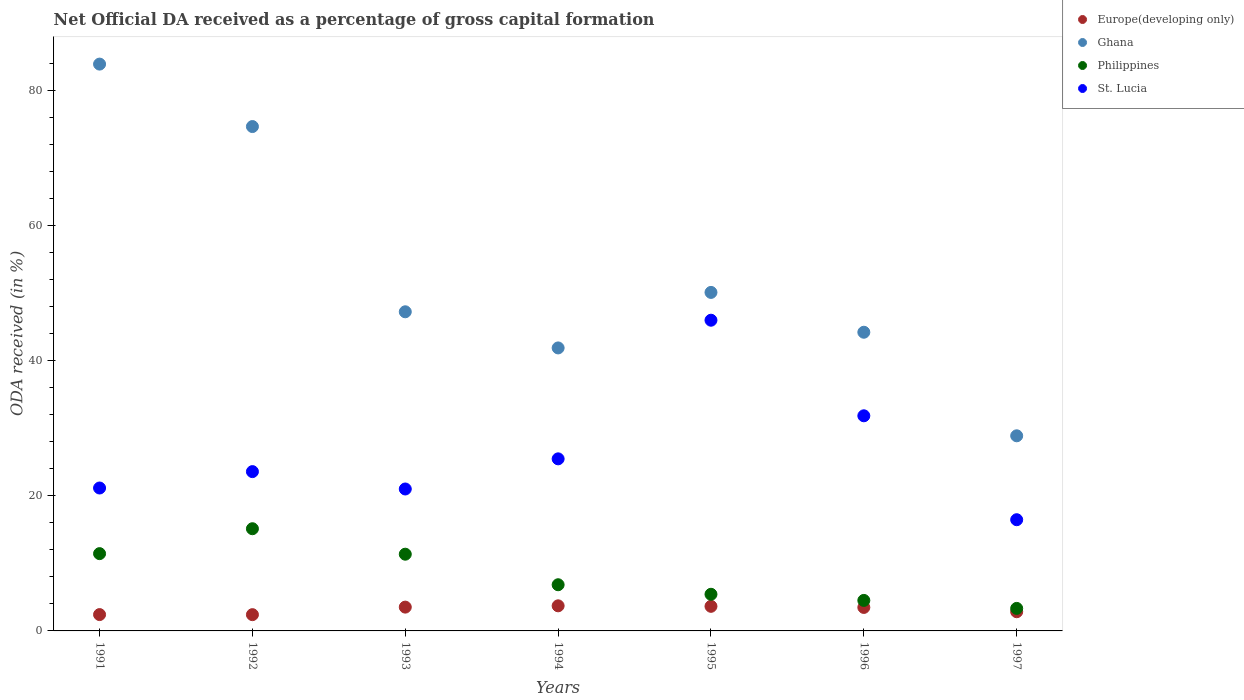What is the net ODA received in St. Lucia in 1991?
Give a very brief answer. 21.15. Across all years, what is the maximum net ODA received in St. Lucia?
Your answer should be compact. 45.98. Across all years, what is the minimum net ODA received in Ghana?
Offer a very short reply. 28.88. In which year was the net ODA received in Ghana minimum?
Your response must be concise. 1997. What is the total net ODA received in Europe(developing only) in the graph?
Your answer should be very brief. 22.01. What is the difference between the net ODA received in Ghana in 1992 and that in 1995?
Offer a very short reply. 24.55. What is the difference between the net ODA received in St. Lucia in 1993 and the net ODA received in Ghana in 1997?
Provide a short and direct response. -7.87. What is the average net ODA received in Europe(developing only) per year?
Your response must be concise. 3.14. In the year 1992, what is the difference between the net ODA received in Ghana and net ODA received in Philippines?
Make the answer very short. 59.52. In how many years, is the net ODA received in Europe(developing only) greater than 56 %?
Your answer should be compact. 0. What is the ratio of the net ODA received in St. Lucia in 1992 to that in 1995?
Your response must be concise. 0.51. What is the difference between the highest and the second highest net ODA received in Ghana?
Give a very brief answer. 9.24. What is the difference between the highest and the lowest net ODA received in Philippines?
Offer a very short reply. 11.79. In how many years, is the net ODA received in Ghana greater than the average net ODA received in Ghana taken over all years?
Provide a succinct answer. 2. Is the sum of the net ODA received in Europe(developing only) in 1991 and 1997 greater than the maximum net ODA received in Ghana across all years?
Your response must be concise. No. Does the net ODA received in Ghana monotonically increase over the years?
Make the answer very short. No. Is the net ODA received in Ghana strictly greater than the net ODA received in St. Lucia over the years?
Provide a short and direct response. Yes. How many dotlines are there?
Your response must be concise. 4. Does the graph contain grids?
Your answer should be compact. No. How are the legend labels stacked?
Your response must be concise. Vertical. What is the title of the graph?
Keep it short and to the point. Net Official DA received as a percentage of gross capital formation. What is the label or title of the X-axis?
Offer a terse response. Years. What is the label or title of the Y-axis?
Your response must be concise. ODA received (in %). What is the ODA received (in %) in Europe(developing only) in 1991?
Offer a terse response. 2.42. What is the ODA received (in %) of Ghana in 1991?
Your response must be concise. 83.88. What is the ODA received (in %) of Philippines in 1991?
Your answer should be very brief. 11.44. What is the ODA received (in %) of St. Lucia in 1991?
Your answer should be compact. 21.15. What is the ODA received (in %) in Europe(developing only) in 1992?
Provide a short and direct response. 2.41. What is the ODA received (in %) in Ghana in 1992?
Your answer should be compact. 74.64. What is the ODA received (in %) in Philippines in 1992?
Provide a succinct answer. 15.12. What is the ODA received (in %) in St. Lucia in 1992?
Offer a terse response. 23.58. What is the ODA received (in %) in Europe(developing only) in 1993?
Your response must be concise. 3.52. What is the ODA received (in %) of Ghana in 1993?
Your answer should be very brief. 47.23. What is the ODA received (in %) in Philippines in 1993?
Offer a very short reply. 11.35. What is the ODA received (in %) of St. Lucia in 1993?
Provide a short and direct response. 21. What is the ODA received (in %) in Europe(developing only) in 1994?
Give a very brief answer. 3.71. What is the ODA received (in %) in Ghana in 1994?
Provide a succinct answer. 41.88. What is the ODA received (in %) in Philippines in 1994?
Your answer should be compact. 6.83. What is the ODA received (in %) in St. Lucia in 1994?
Keep it short and to the point. 25.47. What is the ODA received (in %) of Europe(developing only) in 1995?
Give a very brief answer. 3.64. What is the ODA received (in %) in Ghana in 1995?
Give a very brief answer. 50.09. What is the ODA received (in %) of Philippines in 1995?
Your response must be concise. 5.42. What is the ODA received (in %) of St. Lucia in 1995?
Your answer should be compact. 45.98. What is the ODA received (in %) in Europe(developing only) in 1996?
Your response must be concise. 3.48. What is the ODA received (in %) of Ghana in 1996?
Your answer should be compact. 44.2. What is the ODA received (in %) in Philippines in 1996?
Give a very brief answer. 4.51. What is the ODA received (in %) of St. Lucia in 1996?
Ensure brevity in your answer.  31.84. What is the ODA received (in %) of Europe(developing only) in 1997?
Keep it short and to the point. 2.84. What is the ODA received (in %) in Ghana in 1997?
Your answer should be very brief. 28.88. What is the ODA received (in %) of Philippines in 1997?
Your response must be concise. 3.33. What is the ODA received (in %) in St. Lucia in 1997?
Provide a short and direct response. 16.46. Across all years, what is the maximum ODA received (in %) in Europe(developing only)?
Give a very brief answer. 3.71. Across all years, what is the maximum ODA received (in %) in Ghana?
Give a very brief answer. 83.88. Across all years, what is the maximum ODA received (in %) of Philippines?
Ensure brevity in your answer.  15.12. Across all years, what is the maximum ODA received (in %) in St. Lucia?
Offer a terse response. 45.98. Across all years, what is the minimum ODA received (in %) in Europe(developing only)?
Make the answer very short. 2.41. Across all years, what is the minimum ODA received (in %) in Ghana?
Offer a very short reply. 28.88. Across all years, what is the minimum ODA received (in %) of Philippines?
Keep it short and to the point. 3.33. Across all years, what is the minimum ODA received (in %) of St. Lucia?
Offer a very short reply. 16.46. What is the total ODA received (in %) of Europe(developing only) in the graph?
Provide a short and direct response. 22.01. What is the total ODA received (in %) in Ghana in the graph?
Provide a short and direct response. 370.8. What is the total ODA received (in %) in Philippines in the graph?
Make the answer very short. 58.02. What is the total ODA received (in %) of St. Lucia in the graph?
Keep it short and to the point. 185.47. What is the difference between the ODA received (in %) in Europe(developing only) in 1991 and that in 1992?
Your answer should be compact. 0.01. What is the difference between the ODA received (in %) in Ghana in 1991 and that in 1992?
Give a very brief answer. 9.24. What is the difference between the ODA received (in %) in Philippines in 1991 and that in 1992?
Ensure brevity in your answer.  -3.69. What is the difference between the ODA received (in %) in St. Lucia in 1991 and that in 1992?
Your answer should be compact. -2.43. What is the difference between the ODA received (in %) in Europe(developing only) in 1991 and that in 1993?
Provide a short and direct response. -1.1. What is the difference between the ODA received (in %) of Ghana in 1991 and that in 1993?
Offer a very short reply. 36.65. What is the difference between the ODA received (in %) in Philippines in 1991 and that in 1993?
Offer a very short reply. 0.08. What is the difference between the ODA received (in %) in St. Lucia in 1991 and that in 1993?
Offer a very short reply. 0.14. What is the difference between the ODA received (in %) of Europe(developing only) in 1991 and that in 1994?
Make the answer very short. -1.3. What is the difference between the ODA received (in %) in Ghana in 1991 and that in 1994?
Give a very brief answer. 42. What is the difference between the ODA received (in %) of Philippines in 1991 and that in 1994?
Keep it short and to the point. 4.6. What is the difference between the ODA received (in %) in St. Lucia in 1991 and that in 1994?
Keep it short and to the point. -4.32. What is the difference between the ODA received (in %) of Europe(developing only) in 1991 and that in 1995?
Make the answer very short. -1.22. What is the difference between the ODA received (in %) of Ghana in 1991 and that in 1995?
Your response must be concise. 33.79. What is the difference between the ODA received (in %) in Philippines in 1991 and that in 1995?
Your answer should be very brief. 6.01. What is the difference between the ODA received (in %) in St. Lucia in 1991 and that in 1995?
Provide a succinct answer. -24.83. What is the difference between the ODA received (in %) of Europe(developing only) in 1991 and that in 1996?
Ensure brevity in your answer.  -1.06. What is the difference between the ODA received (in %) of Ghana in 1991 and that in 1996?
Offer a very short reply. 39.68. What is the difference between the ODA received (in %) of Philippines in 1991 and that in 1996?
Ensure brevity in your answer.  6.92. What is the difference between the ODA received (in %) of St. Lucia in 1991 and that in 1996?
Offer a terse response. -10.69. What is the difference between the ODA received (in %) in Europe(developing only) in 1991 and that in 1997?
Provide a short and direct response. -0.42. What is the difference between the ODA received (in %) in Ghana in 1991 and that in 1997?
Your answer should be compact. 55.01. What is the difference between the ODA received (in %) of Philippines in 1991 and that in 1997?
Offer a terse response. 8.1. What is the difference between the ODA received (in %) in St. Lucia in 1991 and that in 1997?
Make the answer very short. 4.69. What is the difference between the ODA received (in %) in Europe(developing only) in 1992 and that in 1993?
Your answer should be very brief. -1.12. What is the difference between the ODA received (in %) in Ghana in 1992 and that in 1993?
Provide a short and direct response. 27.41. What is the difference between the ODA received (in %) in Philippines in 1992 and that in 1993?
Keep it short and to the point. 3.77. What is the difference between the ODA received (in %) of St. Lucia in 1992 and that in 1993?
Provide a succinct answer. 2.57. What is the difference between the ODA received (in %) of Europe(developing only) in 1992 and that in 1994?
Ensure brevity in your answer.  -1.31. What is the difference between the ODA received (in %) in Ghana in 1992 and that in 1994?
Ensure brevity in your answer.  32.76. What is the difference between the ODA received (in %) in Philippines in 1992 and that in 1994?
Offer a terse response. 8.29. What is the difference between the ODA received (in %) in St. Lucia in 1992 and that in 1994?
Make the answer very short. -1.89. What is the difference between the ODA received (in %) in Europe(developing only) in 1992 and that in 1995?
Provide a short and direct response. -1.23. What is the difference between the ODA received (in %) in Ghana in 1992 and that in 1995?
Make the answer very short. 24.55. What is the difference between the ODA received (in %) in Philippines in 1992 and that in 1995?
Offer a very short reply. 9.7. What is the difference between the ODA received (in %) in St. Lucia in 1992 and that in 1995?
Ensure brevity in your answer.  -22.41. What is the difference between the ODA received (in %) in Europe(developing only) in 1992 and that in 1996?
Provide a short and direct response. -1.07. What is the difference between the ODA received (in %) of Ghana in 1992 and that in 1996?
Ensure brevity in your answer.  30.44. What is the difference between the ODA received (in %) of Philippines in 1992 and that in 1996?
Make the answer very short. 10.61. What is the difference between the ODA received (in %) of St. Lucia in 1992 and that in 1996?
Your answer should be very brief. -8.26. What is the difference between the ODA received (in %) in Europe(developing only) in 1992 and that in 1997?
Your answer should be very brief. -0.43. What is the difference between the ODA received (in %) of Ghana in 1992 and that in 1997?
Offer a terse response. 45.76. What is the difference between the ODA received (in %) in Philippines in 1992 and that in 1997?
Ensure brevity in your answer.  11.79. What is the difference between the ODA received (in %) of St. Lucia in 1992 and that in 1997?
Your answer should be compact. 7.12. What is the difference between the ODA received (in %) of Europe(developing only) in 1993 and that in 1994?
Offer a very short reply. -0.19. What is the difference between the ODA received (in %) in Ghana in 1993 and that in 1994?
Provide a short and direct response. 5.35. What is the difference between the ODA received (in %) of Philippines in 1993 and that in 1994?
Make the answer very short. 4.52. What is the difference between the ODA received (in %) in St. Lucia in 1993 and that in 1994?
Offer a terse response. -4.46. What is the difference between the ODA received (in %) of Europe(developing only) in 1993 and that in 1995?
Your response must be concise. -0.12. What is the difference between the ODA received (in %) in Ghana in 1993 and that in 1995?
Offer a very short reply. -2.87. What is the difference between the ODA received (in %) of Philippines in 1993 and that in 1995?
Your answer should be compact. 5.93. What is the difference between the ODA received (in %) of St. Lucia in 1993 and that in 1995?
Offer a terse response. -24.98. What is the difference between the ODA received (in %) of Europe(developing only) in 1993 and that in 1996?
Offer a very short reply. 0.05. What is the difference between the ODA received (in %) in Ghana in 1993 and that in 1996?
Your response must be concise. 3.03. What is the difference between the ODA received (in %) of Philippines in 1993 and that in 1996?
Offer a terse response. 6.84. What is the difference between the ODA received (in %) in St. Lucia in 1993 and that in 1996?
Your answer should be compact. -10.83. What is the difference between the ODA received (in %) of Europe(developing only) in 1993 and that in 1997?
Offer a very short reply. 0.68. What is the difference between the ODA received (in %) of Ghana in 1993 and that in 1997?
Offer a terse response. 18.35. What is the difference between the ODA received (in %) of Philippines in 1993 and that in 1997?
Keep it short and to the point. 8.02. What is the difference between the ODA received (in %) in St. Lucia in 1993 and that in 1997?
Ensure brevity in your answer.  4.55. What is the difference between the ODA received (in %) in Europe(developing only) in 1994 and that in 1995?
Keep it short and to the point. 0.07. What is the difference between the ODA received (in %) in Ghana in 1994 and that in 1995?
Offer a terse response. -8.21. What is the difference between the ODA received (in %) in Philippines in 1994 and that in 1995?
Your answer should be compact. 1.41. What is the difference between the ODA received (in %) in St. Lucia in 1994 and that in 1995?
Your answer should be compact. -20.51. What is the difference between the ODA received (in %) of Europe(developing only) in 1994 and that in 1996?
Give a very brief answer. 0.24. What is the difference between the ODA received (in %) of Ghana in 1994 and that in 1996?
Your response must be concise. -2.32. What is the difference between the ODA received (in %) in Philippines in 1994 and that in 1996?
Offer a terse response. 2.32. What is the difference between the ODA received (in %) in St. Lucia in 1994 and that in 1996?
Your response must be concise. -6.37. What is the difference between the ODA received (in %) of Europe(developing only) in 1994 and that in 1997?
Provide a succinct answer. 0.88. What is the difference between the ODA received (in %) of Ghana in 1994 and that in 1997?
Offer a very short reply. 13. What is the difference between the ODA received (in %) of Philippines in 1994 and that in 1997?
Your answer should be very brief. 3.5. What is the difference between the ODA received (in %) in St. Lucia in 1994 and that in 1997?
Give a very brief answer. 9.01. What is the difference between the ODA received (in %) of Europe(developing only) in 1995 and that in 1996?
Keep it short and to the point. 0.16. What is the difference between the ODA received (in %) in Ghana in 1995 and that in 1996?
Provide a short and direct response. 5.89. What is the difference between the ODA received (in %) in Philippines in 1995 and that in 1996?
Your answer should be compact. 0.91. What is the difference between the ODA received (in %) in St. Lucia in 1995 and that in 1996?
Ensure brevity in your answer.  14.14. What is the difference between the ODA received (in %) in Europe(developing only) in 1995 and that in 1997?
Make the answer very short. 0.8. What is the difference between the ODA received (in %) of Ghana in 1995 and that in 1997?
Your answer should be compact. 21.22. What is the difference between the ODA received (in %) in Philippines in 1995 and that in 1997?
Give a very brief answer. 2.09. What is the difference between the ODA received (in %) in St. Lucia in 1995 and that in 1997?
Offer a terse response. 29.52. What is the difference between the ODA received (in %) in Europe(developing only) in 1996 and that in 1997?
Provide a succinct answer. 0.64. What is the difference between the ODA received (in %) of Ghana in 1996 and that in 1997?
Your answer should be compact. 15.32. What is the difference between the ODA received (in %) of Philippines in 1996 and that in 1997?
Offer a terse response. 1.18. What is the difference between the ODA received (in %) in St. Lucia in 1996 and that in 1997?
Make the answer very short. 15.38. What is the difference between the ODA received (in %) of Europe(developing only) in 1991 and the ODA received (in %) of Ghana in 1992?
Keep it short and to the point. -72.22. What is the difference between the ODA received (in %) of Europe(developing only) in 1991 and the ODA received (in %) of Philippines in 1992?
Your response must be concise. -12.71. What is the difference between the ODA received (in %) of Europe(developing only) in 1991 and the ODA received (in %) of St. Lucia in 1992?
Provide a succinct answer. -21.16. What is the difference between the ODA received (in %) of Ghana in 1991 and the ODA received (in %) of Philippines in 1992?
Provide a short and direct response. 68.76. What is the difference between the ODA received (in %) of Ghana in 1991 and the ODA received (in %) of St. Lucia in 1992?
Keep it short and to the point. 60.31. What is the difference between the ODA received (in %) in Philippines in 1991 and the ODA received (in %) in St. Lucia in 1992?
Offer a terse response. -12.14. What is the difference between the ODA received (in %) in Europe(developing only) in 1991 and the ODA received (in %) in Ghana in 1993?
Keep it short and to the point. -44.81. What is the difference between the ODA received (in %) in Europe(developing only) in 1991 and the ODA received (in %) in Philippines in 1993?
Offer a very short reply. -8.94. What is the difference between the ODA received (in %) in Europe(developing only) in 1991 and the ODA received (in %) in St. Lucia in 1993?
Offer a terse response. -18.59. What is the difference between the ODA received (in %) in Ghana in 1991 and the ODA received (in %) in Philippines in 1993?
Your answer should be compact. 72.53. What is the difference between the ODA received (in %) in Ghana in 1991 and the ODA received (in %) in St. Lucia in 1993?
Your answer should be compact. 62.88. What is the difference between the ODA received (in %) of Philippines in 1991 and the ODA received (in %) of St. Lucia in 1993?
Ensure brevity in your answer.  -9.57. What is the difference between the ODA received (in %) in Europe(developing only) in 1991 and the ODA received (in %) in Ghana in 1994?
Your answer should be very brief. -39.46. What is the difference between the ODA received (in %) of Europe(developing only) in 1991 and the ODA received (in %) of Philippines in 1994?
Offer a terse response. -4.42. What is the difference between the ODA received (in %) in Europe(developing only) in 1991 and the ODA received (in %) in St. Lucia in 1994?
Provide a short and direct response. -23.05. What is the difference between the ODA received (in %) in Ghana in 1991 and the ODA received (in %) in Philippines in 1994?
Provide a short and direct response. 77.05. What is the difference between the ODA received (in %) of Ghana in 1991 and the ODA received (in %) of St. Lucia in 1994?
Your answer should be compact. 58.42. What is the difference between the ODA received (in %) of Philippines in 1991 and the ODA received (in %) of St. Lucia in 1994?
Provide a short and direct response. -14.03. What is the difference between the ODA received (in %) in Europe(developing only) in 1991 and the ODA received (in %) in Ghana in 1995?
Offer a very short reply. -47.68. What is the difference between the ODA received (in %) in Europe(developing only) in 1991 and the ODA received (in %) in Philippines in 1995?
Provide a short and direct response. -3. What is the difference between the ODA received (in %) in Europe(developing only) in 1991 and the ODA received (in %) in St. Lucia in 1995?
Give a very brief answer. -43.56. What is the difference between the ODA received (in %) of Ghana in 1991 and the ODA received (in %) of Philippines in 1995?
Ensure brevity in your answer.  78.46. What is the difference between the ODA received (in %) of Ghana in 1991 and the ODA received (in %) of St. Lucia in 1995?
Provide a short and direct response. 37.9. What is the difference between the ODA received (in %) of Philippines in 1991 and the ODA received (in %) of St. Lucia in 1995?
Offer a terse response. -34.54. What is the difference between the ODA received (in %) of Europe(developing only) in 1991 and the ODA received (in %) of Ghana in 1996?
Provide a short and direct response. -41.78. What is the difference between the ODA received (in %) in Europe(developing only) in 1991 and the ODA received (in %) in Philippines in 1996?
Make the answer very short. -2.1. What is the difference between the ODA received (in %) in Europe(developing only) in 1991 and the ODA received (in %) in St. Lucia in 1996?
Ensure brevity in your answer.  -29.42. What is the difference between the ODA received (in %) in Ghana in 1991 and the ODA received (in %) in Philippines in 1996?
Give a very brief answer. 79.37. What is the difference between the ODA received (in %) in Ghana in 1991 and the ODA received (in %) in St. Lucia in 1996?
Ensure brevity in your answer.  52.05. What is the difference between the ODA received (in %) in Philippines in 1991 and the ODA received (in %) in St. Lucia in 1996?
Ensure brevity in your answer.  -20.4. What is the difference between the ODA received (in %) in Europe(developing only) in 1991 and the ODA received (in %) in Ghana in 1997?
Provide a short and direct response. -26.46. What is the difference between the ODA received (in %) of Europe(developing only) in 1991 and the ODA received (in %) of Philippines in 1997?
Make the answer very short. -0.91. What is the difference between the ODA received (in %) in Europe(developing only) in 1991 and the ODA received (in %) in St. Lucia in 1997?
Your response must be concise. -14.04. What is the difference between the ODA received (in %) in Ghana in 1991 and the ODA received (in %) in Philippines in 1997?
Your answer should be compact. 80.55. What is the difference between the ODA received (in %) in Ghana in 1991 and the ODA received (in %) in St. Lucia in 1997?
Provide a short and direct response. 67.42. What is the difference between the ODA received (in %) in Philippines in 1991 and the ODA received (in %) in St. Lucia in 1997?
Ensure brevity in your answer.  -5.02. What is the difference between the ODA received (in %) in Europe(developing only) in 1992 and the ODA received (in %) in Ghana in 1993?
Your answer should be very brief. -44.82. What is the difference between the ODA received (in %) in Europe(developing only) in 1992 and the ODA received (in %) in Philippines in 1993?
Your answer should be compact. -8.95. What is the difference between the ODA received (in %) of Europe(developing only) in 1992 and the ODA received (in %) of St. Lucia in 1993?
Your answer should be compact. -18.6. What is the difference between the ODA received (in %) of Ghana in 1992 and the ODA received (in %) of Philippines in 1993?
Keep it short and to the point. 63.29. What is the difference between the ODA received (in %) in Ghana in 1992 and the ODA received (in %) in St. Lucia in 1993?
Offer a very short reply. 53.64. What is the difference between the ODA received (in %) in Philippines in 1992 and the ODA received (in %) in St. Lucia in 1993?
Provide a short and direct response. -5.88. What is the difference between the ODA received (in %) in Europe(developing only) in 1992 and the ODA received (in %) in Ghana in 1994?
Your answer should be compact. -39.47. What is the difference between the ODA received (in %) of Europe(developing only) in 1992 and the ODA received (in %) of Philippines in 1994?
Provide a succinct answer. -4.43. What is the difference between the ODA received (in %) of Europe(developing only) in 1992 and the ODA received (in %) of St. Lucia in 1994?
Keep it short and to the point. -23.06. What is the difference between the ODA received (in %) of Ghana in 1992 and the ODA received (in %) of Philippines in 1994?
Provide a short and direct response. 67.81. What is the difference between the ODA received (in %) in Ghana in 1992 and the ODA received (in %) in St. Lucia in 1994?
Your answer should be very brief. 49.17. What is the difference between the ODA received (in %) of Philippines in 1992 and the ODA received (in %) of St. Lucia in 1994?
Offer a terse response. -10.34. What is the difference between the ODA received (in %) of Europe(developing only) in 1992 and the ODA received (in %) of Ghana in 1995?
Provide a short and direct response. -47.69. What is the difference between the ODA received (in %) in Europe(developing only) in 1992 and the ODA received (in %) in Philippines in 1995?
Offer a terse response. -3.02. What is the difference between the ODA received (in %) of Europe(developing only) in 1992 and the ODA received (in %) of St. Lucia in 1995?
Keep it short and to the point. -43.57. What is the difference between the ODA received (in %) in Ghana in 1992 and the ODA received (in %) in Philippines in 1995?
Your answer should be compact. 69.22. What is the difference between the ODA received (in %) of Ghana in 1992 and the ODA received (in %) of St. Lucia in 1995?
Ensure brevity in your answer.  28.66. What is the difference between the ODA received (in %) of Philippines in 1992 and the ODA received (in %) of St. Lucia in 1995?
Provide a short and direct response. -30.86. What is the difference between the ODA received (in %) in Europe(developing only) in 1992 and the ODA received (in %) in Ghana in 1996?
Your response must be concise. -41.79. What is the difference between the ODA received (in %) in Europe(developing only) in 1992 and the ODA received (in %) in Philippines in 1996?
Provide a short and direct response. -2.11. What is the difference between the ODA received (in %) in Europe(developing only) in 1992 and the ODA received (in %) in St. Lucia in 1996?
Provide a short and direct response. -29.43. What is the difference between the ODA received (in %) of Ghana in 1992 and the ODA received (in %) of Philippines in 1996?
Ensure brevity in your answer.  70.13. What is the difference between the ODA received (in %) of Ghana in 1992 and the ODA received (in %) of St. Lucia in 1996?
Your answer should be very brief. 42.8. What is the difference between the ODA received (in %) in Philippines in 1992 and the ODA received (in %) in St. Lucia in 1996?
Provide a short and direct response. -16.71. What is the difference between the ODA received (in %) in Europe(developing only) in 1992 and the ODA received (in %) in Ghana in 1997?
Give a very brief answer. -26.47. What is the difference between the ODA received (in %) of Europe(developing only) in 1992 and the ODA received (in %) of Philippines in 1997?
Ensure brevity in your answer.  -0.93. What is the difference between the ODA received (in %) in Europe(developing only) in 1992 and the ODA received (in %) in St. Lucia in 1997?
Your answer should be very brief. -14.05. What is the difference between the ODA received (in %) in Ghana in 1992 and the ODA received (in %) in Philippines in 1997?
Ensure brevity in your answer.  71.31. What is the difference between the ODA received (in %) in Ghana in 1992 and the ODA received (in %) in St. Lucia in 1997?
Provide a succinct answer. 58.18. What is the difference between the ODA received (in %) in Philippines in 1992 and the ODA received (in %) in St. Lucia in 1997?
Offer a terse response. -1.33. What is the difference between the ODA received (in %) of Europe(developing only) in 1993 and the ODA received (in %) of Ghana in 1994?
Ensure brevity in your answer.  -38.36. What is the difference between the ODA received (in %) of Europe(developing only) in 1993 and the ODA received (in %) of Philippines in 1994?
Your answer should be compact. -3.31. What is the difference between the ODA received (in %) of Europe(developing only) in 1993 and the ODA received (in %) of St. Lucia in 1994?
Ensure brevity in your answer.  -21.94. What is the difference between the ODA received (in %) of Ghana in 1993 and the ODA received (in %) of Philippines in 1994?
Your answer should be very brief. 40.39. What is the difference between the ODA received (in %) in Ghana in 1993 and the ODA received (in %) in St. Lucia in 1994?
Make the answer very short. 21.76. What is the difference between the ODA received (in %) in Philippines in 1993 and the ODA received (in %) in St. Lucia in 1994?
Keep it short and to the point. -14.11. What is the difference between the ODA received (in %) of Europe(developing only) in 1993 and the ODA received (in %) of Ghana in 1995?
Your answer should be compact. -46.57. What is the difference between the ODA received (in %) of Europe(developing only) in 1993 and the ODA received (in %) of Philippines in 1995?
Your answer should be compact. -1.9. What is the difference between the ODA received (in %) in Europe(developing only) in 1993 and the ODA received (in %) in St. Lucia in 1995?
Your answer should be very brief. -42.46. What is the difference between the ODA received (in %) of Ghana in 1993 and the ODA received (in %) of Philippines in 1995?
Your answer should be compact. 41.8. What is the difference between the ODA received (in %) in Ghana in 1993 and the ODA received (in %) in St. Lucia in 1995?
Keep it short and to the point. 1.25. What is the difference between the ODA received (in %) of Philippines in 1993 and the ODA received (in %) of St. Lucia in 1995?
Make the answer very short. -34.63. What is the difference between the ODA received (in %) of Europe(developing only) in 1993 and the ODA received (in %) of Ghana in 1996?
Ensure brevity in your answer.  -40.68. What is the difference between the ODA received (in %) in Europe(developing only) in 1993 and the ODA received (in %) in Philippines in 1996?
Offer a very short reply. -0.99. What is the difference between the ODA received (in %) in Europe(developing only) in 1993 and the ODA received (in %) in St. Lucia in 1996?
Provide a short and direct response. -28.31. What is the difference between the ODA received (in %) of Ghana in 1993 and the ODA received (in %) of Philippines in 1996?
Ensure brevity in your answer.  42.71. What is the difference between the ODA received (in %) of Ghana in 1993 and the ODA received (in %) of St. Lucia in 1996?
Your answer should be very brief. 15.39. What is the difference between the ODA received (in %) of Philippines in 1993 and the ODA received (in %) of St. Lucia in 1996?
Give a very brief answer. -20.48. What is the difference between the ODA received (in %) of Europe(developing only) in 1993 and the ODA received (in %) of Ghana in 1997?
Keep it short and to the point. -25.35. What is the difference between the ODA received (in %) of Europe(developing only) in 1993 and the ODA received (in %) of Philippines in 1997?
Give a very brief answer. 0.19. What is the difference between the ODA received (in %) in Europe(developing only) in 1993 and the ODA received (in %) in St. Lucia in 1997?
Your answer should be very brief. -12.93. What is the difference between the ODA received (in %) of Ghana in 1993 and the ODA received (in %) of Philippines in 1997?
Offer a very short reply. 43.9. What is the difference between the ODA received (in %) of Ghana in 1993 and the ODA received (in %) of St. Lucia in 1997?
Provide a short and direct response. 30.77. What is the difference between the ODA received (in %) of Philippines in 1993 and the ODA received (in %) of St. Lucia in 1997?
Offer a very short reply. -5.1. What is the difference between the ODA received (in %) of Europe(developing only) in 1994 and the ODA received (in %) of Ghana in 1995?
Your answer should be very brief. -46.38. What is the difference between the ODA received (in %) of Europe(developing only) in 1994 and the ODA received (in %) of Philippines in 1995?
Your answer should be compact. -1.71. What is the difference between the ODA received (in %) in Europe(developing only) in 1994 and the ODA received (in %) in St. Lucia in 1995?
Ensure brevity in your answer.  -42.27. What is the difference between the ODA received (in %) in Ghana in 1994 and the ODA received (in %) in Philippines in 1995?
Make the answer very short. 36.46. What is the difference between the ODA received (in %) of Philippines in 1994 and the ODA received (in %) of St. Lucia in 1995?
Keep it short and to the point. -39.15. What is the difference between the ODA received (in %) of Europe(developing only) in 1994 and the ODA received (in %) of Ghana in 1996?
Keep it short and to the point. -40.49. What is the difference between the ODA received (in %) of Europe(developing only) in 1994 and the ODA received (in %) of Philippines in 1996?
Provide a short and direct response. -0.8. What is the difference between the ODA received (in %) of Europe(developing only) in 1994 and the ODA received (in %) of St. Lucia in 1996?
Ensure brevity in your answer.  -28.12. What is the difference between the ODA received (in %) of Ghana in 1994 and the ODA received (in %) of Philippines in 1996?
Your answer should be very brief. 37.37. What is the difference between the ODA received (in %) in Ghana in 1994 and the ODA received (in %) in St. Lucia in 1996?
Ensure brevity in your answer.  10.04. What is the difference between the ODA received (in %) of Philippines in 1994 and the ODA received (in %) of St. Lucia in 1996?
Ensure brevity in your answer.  -25. What is the difference between the ODA received (in %) of Europe(developing only) in 1994 and the ODA received (in %) of Ghana in 1997?
Keep it short and to the point. -25.16. What is the difference between the ODA received (in %) in Europe(developing only) in 1994 and the ODA received (in %) in Philippines in 1997?
Offer a very short reply. 0.38. What is the difference between the ODA received (in %) in Europe(developing only) in 1994 and the ODA received (in %) in St. Lucia in 1997?
Offer a very short reply. -12.74. What is the difference between the ODA received (in %) in Ghana in 1994 and the ODA received (in %) in Philippines in 1997?
Keep it short and to the point. 38.55. What is the difference between the ODA received (in %) in Ghana in 1994 and the ODA received (in %) in St. Lucia in 1997?
Your response must be concise. 25.42. What is the difference between the ODA received (in %) of Philippines in 1994 and the ODA received (in %) of St. Lucia in 1997?
Ensure brevity in your answer.  -9.62. What is the difference between the ODA received (in %) of Europe(developing only) in 1995 and the ODA received (in %) of Ghana in 1996?
Provide a short and direct response. -40.56. What is the difference between the ODA received (in %) of Europe(developing only) in 1995 and the ODA received (in %) of Philippines in 1996?
Offer a terse response. -0.87. What is the difference between the ODA received (in %) in Europe(developing only) in 1995 and the ODA received (in %) in St. Lucia in 1996?
Your answer should be compact. -28.2. What is the difference between the ODA received (in %) of Ghana in 1995 and the ODA received (in %) of Philippines in 1996?
Make the answer very short. 45.58. What is the difference between the ODA received (in %) of Ghana in 1995 and the ODA received (in %) of St. Lucia in 1996?
Your answer should be very brief. 18.26. What is the difference between the ODA received (in %) in Philippines in 1995 and the ODA received (in %) in St. Lucia in 1996?
Offer a very short reply. -26.41. What is the difference between the ODA received (in %) of Europe(developing only) in 1995 and the ODA received (in %) of Ghana in 1997?
Keep it short and to the point. -25.24. What is the difference between the ODA received (in %) in Europe(developing only) in 1995 and the ODA received (in %) in Philippines in 1997?
Provide a succinct answer. 0.31. What is the difference between the ODA received (in %) of Europe(developing only) in 1995 and the ODA received (in %) of St. Lucia in 1997?
Your answer should be compact. -12.82. What is the difference between the ODA received (in %) of Ghana in 1995 and the ODA received (in %) of Philippines in 1997?
Offer a terse response. 46.76. What is the difference between the ODA received (in %) in Ghana in 1995 and the ODA received (in %) in St. Lucia in 1997?
Your answer should be compact. 33.64. What is the difference between the ODA received (in %) in Philippines in 1995 and the ODA received (in %) in St. Lucia in 1997?
Provide a succinct answer. -11.03. What is the difference between the ODA received (in %) in Europe(developing only) in 1996 and the ODA received (in %) in Ghana in 1997?
Provide a succinct answer. -25.4. What is the difference between the ODA received (in %) in Europe(developing only) in 1996 and the ODA received (in %) in Philippines in 1997?
Provide a succinct answer. 0.14. What is the difference between the ODA received (in %) in Europe(developing only) in 1996 and the ODA received (in %) in St. Lucia in 1997?
Give a very brief answer. -12.98. What is the difference between the ODA received (in %) in Ghana in 1996 and the ODA received (in %) in Philippines in 1997?
Ensure brevity in your answer.  40.87. What is the difference between the ODA received (in %) in Ghana in 1996 and the ODA received (in %) in St. Lucia in 1997?
Offer a very short reply. 27.74. What is the difference between the ODA received (in %) of Philippines in 1996 and the ODA received (in %) of St. Lucia in 1997?
Offer a very short reply. -11.94. What is the average ODA received (in %) in Europe(developing only) per year?
Ensure brevity in your answer.  3.14. What is the average ODA received (in %) in Ghana per year?
Offer a very short reply. 52.97. What is the average ODA received (in %) of Philippines per year?
Ensure brevity in your answer.  8.29. What is the average ODA received (in %) in St. Lucia per year?
Ensure brevity in your answer.  26.5. In the year 1991, what is the difference between the ODA received (in %) of Europe(developing only) and ODA received (in %) of Ghana?
Provide a succinct answer. -81.46. In the year 1991, what is the difference between the ODA received (in %) in Europe(developing only) and ODA received (in %) in Philippines?
Your answer should be very brief. -9.02. In the year 1991, what is the difference between the ODA received (in %) of Europe(developing only) and ODA received (in %) of St. Lucia?
Ensure brevity in your answer.  -18.73. In the year 1991, what is the difference between the ODA received (in %) of Ghana and ODA received (in %) of Philippines?
Give a very brief answer. 72.44. In the year 1991, what is the difference between the ODA received (in %) in Ghana and ODA received (in %) in St. Lucia?
Offer a terse response. 62.73. In the year 1991, what is the difference between the ODA received (in %) of Philippines and ODA received (in %) of St. Lucia?
Ensure brevity in your answer.  -9.71. In the year 1992, what is the difference between the ODA received (in %) in Europe(developing only) and ODA received (in %) in Ghana?
Your answer should be very brief. -72.23. In the year 1992, what is the difference between the ODA received (in %) in Europe(developing only) and ODA received (in %) in Philippines?
Your response must be concise. -12.72. In the year 1992, what is the difference between the ODA received (in %) of Europe(developing only) and ODA received (in %) of St. Lucia?
Keep it short and to the point. -21.17. In the year 1992, what is the difference between the ODA received (in %) in Ghana and ODA received (in %) in Philippines?
Offer a very short reply. 59.52. In the year 1992, what is the difference between the ODA received (in %) in Ghana and ODA received (in %) in St. Lucia?
Provide a succinct answer. 51.07. In the year 1992, what is the difference between the ODA received (in %) of Philippines and ODA received (in %) of St. Lucia?
Provide a succinct answer. -8.45. In the year 1993, what is the difference between the ODA received (in %) of Europe(developing only) and ODA received (in %) of Ghana?
Provide a succinct answer. -43.71. In the year 1993, what is the difference between the ODA received (in %) of Europe(developing only) and ODA received (in %) of Philippines?
Provide a short and direct response. -7.83. In the year 1993, what is the difference between the ODA received (in %) in Europe(developing only) and ODA received (in %) in St. Lucia?
Your response must be concise. -17.48. In the year 1993, what is the difference between the ODA received (in %) in Ghana and ODA received (in %) in Philippines?
Provide a short and direct response. 35.87. In the year 1993, what is the difference between the ODA received (in %) of Ghana and ODA received (in %) of St. Lucia?
Your answer should be very brief. 26.22. In the year 1993, what is the difference between the ODA received (in %) in Philippines and ODA received (in %) in St. Lucia?
Give a very brief answer. -9.65. In the year 1994, what is the difference between the ODA received (in %) in Europe(developing only) and ODA received (in %) in Ghana?
Give a very brief answer. -38.17. In the year 1994, what is the difference between the ODA received (in %) in Europe(developing only) and ODA received (in %) in Philippines?
Your response must be concise. -3.12. In the year 1994, what is the difference between the ODA received (in %) in Europe(developing only) and ODA received (in %) in St. Lucia?
Offer a terse response. -21.75. In the year 1994, what is the difference between the ODA received (in %) of Ghana and ODA received (in %) of Philippines?
Offer a very short reply. 35.05. In the year 1994, what is the difference between the ODA received (in %) in Ghana and ODA received (in %) in St. Lucia?
Your response must be concise. 16.41. In the year 1994, what is the difference between the ODA received (in %) of Philippines and ODA received (in %) of St. Lucia?
Offer a terse response. -18.63. In the year 1995, what is the difference between the ODA received (in %) of Europe(developing only) and ODA received (in %) of Ghana?
Keep it short and to the point. -46.46. In the year 1995, what is the difference between the ODA received (in %) in Europe(developing only) and ODA received (in %) in Philippines?
Provide a succinct answer. -1.78. In the year 1995, what is the difference between the ODA received (in %) in Europe(developing only) and ODA received (in %) in St. Lucia?
Give a very brief answer. -42.34. In the year 1995, what is the difference between the ODA received (in %) of Ghana and ODA received (in %) of Philippines?
Your answer should be compact. 44.67. In the year 1995, what is the difference between the ODA received (in %) in Ghana and ODA received (in %) in St. Lucia?
Offer a very short reply. 4.11. In the year 1995, what is the difference between the ODA received (in %) of Philippines and ODA received (in %) of St. Lucia?
Your answer should be compact. -40.56. In the year 1996, what is the difference between the ODA received (in %) in Europe(developing only) and ODA received (in %) in Ghana?
Offer a terse response. -40.72. In the year 1996, what is the difference between the ODA received (in %) of Europe(developing only) and ODA received (in %) of Philippines?
Your answer should be compact. -1.04. In the year 1996, what is the difference between the ODA received (in %) of Europe(developing only) and ODA received (in %) of St. Lucia?
Your response must be concise. -28.36. In the year 1996, what is the difference between the ODA received (in %) in Ghana and ODA received (in %) in Philippines?
Keep it short and to the point. 39.69. In the year 1996, what is the difference between the ODA received (in %) of Ghana and ODA received (in %) of St. Lucia?
Provide a short and direct response. 12.36. In the year 1996, what is the difference between the ODA received (in %) in Philippines and ODA received (in %) in St. Lucia?
Your response must be concise. -27.32. In the year 1997, what is the difference between the ODA received (in %) in Europe(developing only) and ODA received (in %) in Ghana?
Provide a succinct answer. -26.04. In the year 1997, what is the difference between the ODA received (in %) in Europe(developing only) and ODA received (in %) in Philippines?
Give a very brief answer. -0.49. In the year 1997, what is the difference between the ODA received (in %) of Europe(developing only) and ODA received (in %) of St. Lucia?
Your answer should be very brief. -13.62. In the year 1997, what is the difference between the ODA received (in %) in Ghana and ODA received (in %) in Philippines?
Keep it short and to the point. 25.54. In the year 1997, what is the difference between the ODA received (in %) of Ghana and ODA received (in %) of St. Lucia?
Provide a short and direct response. 12.42. In the year 1997, what is the difference between the ODA received (in %) in Philippines and ODA received (in %) in St. Lucia?
Your answer should be compact. -13.12. What is the ratio of the ODA received (in %) of Europe(developing only) in 1991 to that in 1992?
Give a very brief answer. 1. What is the ratio of the ODA received (in %) in Ghana in 1991 to that in 1992?
Provide a succinct answer. 1.12. What is the ratio of the ODA received (in %) of Philippines in 1991 to that in 1992?
Provide a succinct answer. 0.76. What is the ratio of the ODA received (in %) in St. Lucia in 1991 to that in 1992?
Give a very brief answer. 0.9. What is the ratio of the ODA received (in %) of Europe(developing only) in 1991 to that in 1993?
Offer a very short reply. 0.69. What is the ratio of the ODA received (in %) of Ghana in 1991 to that in 1993?
Ensure brevity in your answer.  1.78. What is the ratio of the ODA received (in %) in Philippines in 1991 to that in 1993?
Provide a succinct answer. 1.01. What is the ratio of the ODA received (in %) in Europe(developing only) in 1991 to that in 1994?
Make the answer very short. 0.65. What is the ratio of the ODA received (in %) of Ghana in 1991 to that in 1994?
Give a very brief answer. 2. What is the ratio of the ODA received (in %) of Philippines in 1991 to that in 1994?
Offer a terse response. 1.67. What is the ratio of the ODA received (in %) of St. Lucia in 1991 to that in 1994?
Offer a very short reply. 0.83. What is the ratio of the ODA received (in %) in Europe(developing only) in 1991 to that in 1995?
Offer a terse response. 0.66. What is the ratio of the ODA received (in %) of Ghana in 1991 to that in 1995?
Give a very brief answer. 1.67. What is the ratio of the ODA received (in %) in Philippines in 1991 to that in 1995?
Offer a terse response. 2.11. What is the ratio of the ODA received (in %) in St. Lucia in 1991 to that in 1995?
Your response must be concise. 0.46. What is the ratio of the ODA received (in %) in Europe(developing only) in 1991 to that in 1996?
Give a very brief answer. 0.7. What is the ratio of the ODA received (in %) of Ghana in 1991 to that in 1996?
Offer a very short reply. 1.9. What is the ratio of the ODA received (in %) of Philippines in 1991 to that in 1996?
Offer a terse response. 2.53. What is the ratio of the ODA received (in %) of St. Lucia in 1991 to that in 1996?
Offer a terse response. 0.66. What is the ratio of the ODA received (in %) of Europe(developing only) in 1991 to that in 1997?
Provide a short and direct response. 0.85. What is the ratio of the ODA received (in %) in Ghana in 1991 to that in 1997?
Your answer should be very brief. 2.9. What is the ratio of the ODA received (in %) in Philippines in 1991 to that in 1997?
Make the answer very short. 3.43. What is the ratio of the ODA received (in %) in St. Lucia in 1991 to that in 1997?
Provide a succinct answer. 1.29. What is the ratio of the ODA received (in %) of Europe(developing only) in 1992 to that in 1993?
Offer a terse response. 0.68. What is the ratio of the ODA received (in %) in Ghana in 1992 to that in 1993?
Keep it short and to the point. 1.58. What is the ratio of the ODA received (in %) in Philippines in 1992 to that in 1993?
Provide a short and direct response. 1.33. What is the ratio of the ODA received (in %) of St. Lucia in 1992 to that in 1993?
Make the answer very short. 1.12. What is the ratio of the ODA received (in %) in Europe(developing only) in 1992 to that in 1994?
Offer a terse response. 0.65. What is the ratio of the ODA received (in %) of Ghana in 1992 to that in 1994?
Your answer should be very brief. 1.78. What is the ratio of the ODA received (in %) in Philippines in 1992 to that in 1994?
Your answer should be compact. 2.21. What is the ratio of the ODA received (in %) of St. Lucia in 1992 to that in 1994?
Offer a terse response. 0.93. What is the ratio of the ODA received (in %) in Europe(developing only) in 1992 to that in 1995?
Your answer should be compact. 0.66. What is the ratio of the ODA received (in %) of Ghana in 1992 to that in 1995?
Provide a succinct answer. 1.49. What is the ratio of the ODA received (in %) in Philippines in 1992 to that in 1995?
Make the answer very short. 2.79. What is the ratio of the ODA received (in %) of St. Lucia in 1992 to that in 1995?
Offer a terse response. 0.51. What is the ratio of the ODA received (in %) in Europe(developing only) in 1992 to that in 1996?
Your response must be concise. 0.69. What is the ratio of the ODA received (in %) of Ghana in 1992 to that in 1996?
Offer a very short reply. 1.69. What is the ratio of the ODA received (in %) of Philippines in 1992 to that in 1996?
Offer a terse response. 3.35. What is the ratio of the ODA received (in %) in St. Lucia in 1992 to that in 1996?
Offer a very short reply. 0.74. What is the ratio of the ODA received (in %) of Europe(developing only) in 1992 to that in 1997?
Your answer should be very brief. 0.85. What is the ratio of the ODA received (in %) in Ghana in 1992 to that in 1997?
Give a very brief answer. 2.58. What is the ratio of the ODA received (in %) of Philippines in 1992 to that in 1997?
Give a very brief answer. 4.54. What is the ratio of the ODA received (in %) of St. Lucia in 1992 to that in 1997?
Keep it short and to the point. 1.43. What is the ratio of the ODA received (in %) of Europe(developing only) in 1993 to that in 1994?
Your answer should be very brief. 0.95. What is the ratio of the ODA received (in %) of Ghana in 1993 to that in 1994?
Make the answer very short. 1.13. What is the ratio of the ODA received (in %) in Philippines in 1993 to that in 1994?
Your answer should be compact. 1.66. What is the ratio of the ODA received (in %) of St. Lucia in 1993 to that in 1994?
Your response must be concise. 0.82. What is the ratio of the ODA received (in %) of Europe(developing only) in 1993 to that in 1995?
Your response must be concise. 0.97. What is the ratio of the ODA received (in %) of Ghana in 1993 to that in 1995?
Your answer should be very brief. 0.94. What is the ratio of the ODA received (in %) of Philippines in 1993 to that in 1995?
Your answer should be very brief. 2.09. What is the ratio of the ODA received (in %) in St. Lucia in 1993 to that in 1995?
Give a very brief answer. 0.46. What is the ratio of the ODA received (in %) of Europe(developing only) in 1993 to that in 1996?
Make the answer very short. 1.01. What is the ratio of the ODA received (in %) of Ghana in 1993 to that in 1996?
Your answer should be compact. 1.07. What is the ratio of the ODA received (in %) of Philippines in 1993 to that in 1996?
Your answer should be compact. 2.52. What is the ratio of the ODA received (in %) of St. Lucia in 1993 to that in 1996?
Your response must be concise. 0.66. What is the ratio of the ODA received (in %) of Europe(developing only) in 1993 to that in 1997?
Your answer should be very brief. 1.24. What is the ratio of the ODA received (in %) of Ghana in 1993 to that in 1997?
Offer a very short reply. 1.64. What is the ratio of the ODA received (in %) in Philippines in 1993 to that in 1997?
Your response must be concise. 3.41. What is the ratio of the ODA received (in %) of St. Lucia in 1993 to that in 1997?
Your answer should be very brief. 1.28. What is the ratio of the ODA received (in %) in Europe(developing only) in 1994 to that in 1995?
Make the answer very short. 1.02. What is the ratio of the ODA received (in %) in Ghana in 1994 to that in 1995?
Your answer should be compact. 0.84. What is the ratio of the ODA received (in %) of Philippines in 1994 to that in 1995?
Ensure brevity in your answer.  1.26. What is the ratio of the ODA received (in %) in St. Lucia in 1994 to that in 1995?
Provide a short and direct response. 0.55. What is the ratio of the ODA received (in %) of Europe(developing only) in 1994 to that in 1996?
Keep it short and to the point. 1.07. What is the ratio of the ODA received (in %) of Ghana in 1994 to that in 1996?
Make the answer very short. 0.95. What is the ratio of the ODA received (in %) in Philippines in 1994 to that in 1996?
Make the answer very short. 1.51. What is the ratio of the ODA received (in %) in St. Lucia in 1994 to that in 1996?
Provide a short and direct response. 0.8. What is the ratio of the ODA received (in %) of Europe(developing only) in 1994 to that in 1997?
Offer a terse response. 1.31. What is the ratio of the ODA received (in %) of Ghana in 1994 to that in 1997?
Provide a succinct answer. 1.45. What is the ratio of the ODA received (in %) of Philippines in 1994 to that in 1997?
Provide a succinct answer. 2.05. What is the ratio of the ODA received (in %) of St. Lucia in 1994 to that in 1997?
Provide a succinct answer. 1.55. What is the ratio of the ODA received (in %) in Europe(developing only) in 1995 to that in 1996?
Offer a terse response. 1.05. What is the ratio of the ODA received (in %) in Ghana in 1995 to that in 1996?
Your response must be concise. 1.13. What is the ratio of the ODA received (in %) in Philippines in 1995 to that in 1996?
Provide a succinct answer. 1.2. What is the ratio of the ODA received (in %) in St. Lucia in 1995 to that in 1996?
Provide a short and direct response. 1.44. What is the ratio of the ODA received (in %) of Europe(developing only) in 1995 to that in 1997?
Give a very brief answer. 1.28. What is the ratio of the ODA received (in %) in Ghana in 1995 to that in 1997?
Offer a terse response. 1.73. What is the ratio of the ODA received (in %) of Philippines in 1995 to that in 1997?
Your answer should be compact. 1.63. What is the ratio of the ODA received (in %) in St. Lucia in 1995 to that in 1997?
Provide a succinct answer. 2.79. What is the ratio of the ODA received (in %) in Europe(developing only) in 1996 to that in 1997?
Give a very brief answer. 1.23. What is the ratio of the ODA received (in %) in Ghana in 1996 to that in 1997?
Offer a terse response. 1.53. What is the ratio of the ODA received (in %) of Philippines in 1996 to that in 1997?
Make the answer very short. 1.35. What is the ratio of the ODA received (in %) of St. Lucia in 1996 to that in 1997?
Make the answer very short. 1.93. What is the difference between the highest and the second highest ODA received (in %) of Europe(developing only)?
Provide a succinct answer. 0.07. What is the difference between the highest and the second highest ODA received (in %) in Ghana?
Your response must be concise. 9.24. What is the difference between the highest and the second highest ODA received (in %) in Philippines?
Keep it short and to the point. 3.69. What is the difference between the highest and the second highest ODA received (in %) in St. Lucia?
Make the answer very short. 14.14. What is the difference between the highest and the lowest ODA received (in %) of Europe(developing only)?
Your answer should be compact. 1.31. What is the difference between the highest and the lowest ODA received (in %) of Ghana?
Make the answer very short. 55.01. What is the difference between the highest and the lowest ODA received (in %) of Philippines?
Your answer should be compact. 11.79. What is the difference between the highest and the lowest ODA received (in %) in St. Lucia?
Give a very brief answer. 29.52. 